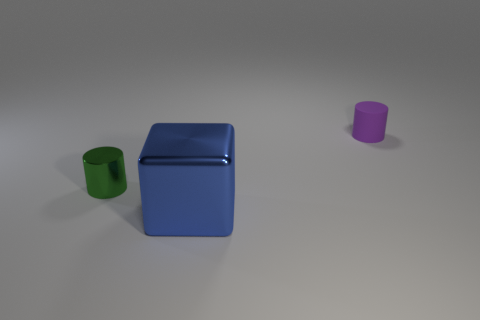Add 3 purple rubber things. How many objects exist? 6 Subtract all blocks. How many objects are left? 2 Add 3 small green metal cylinders. How many small green metal cylinders exist? 4 Subtract 0 cyan cylinders. How many objects are left? 3 Subtract all red rubber cylinders. Subtract all tiny things. How many objects are left? 1 Add 1 small purple objects. How many small purple objects are left? 2 